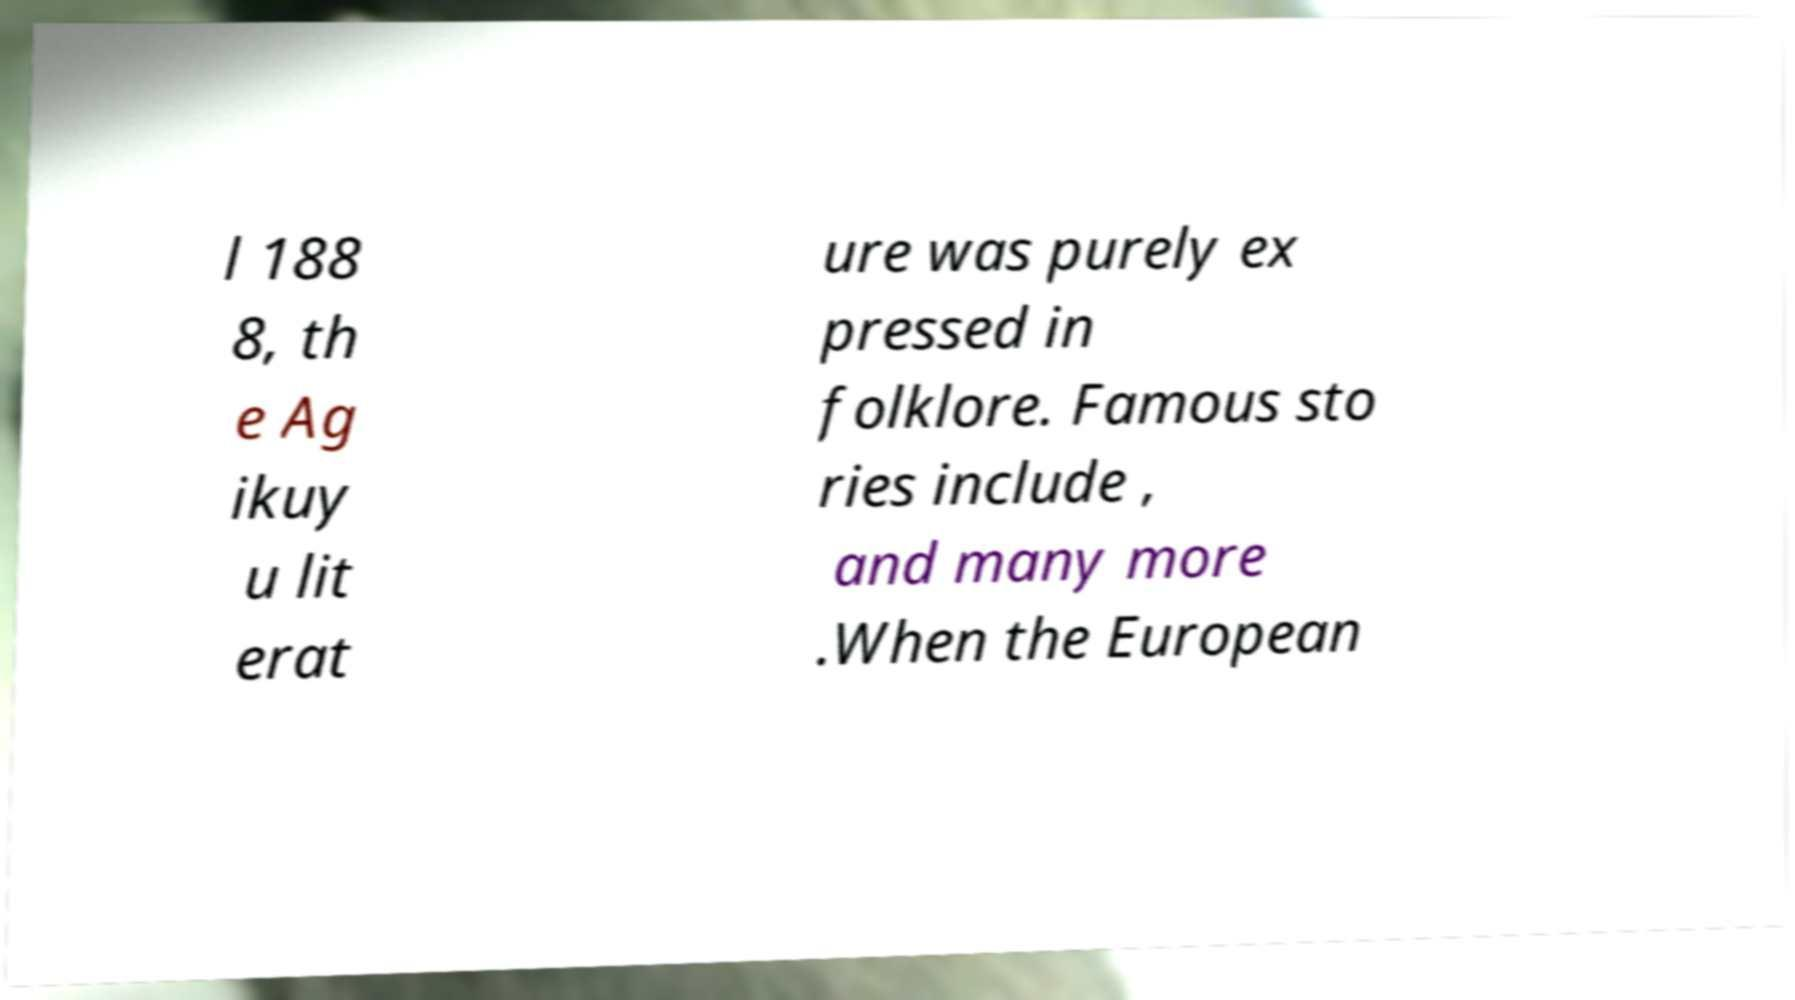There's text embedded in this image that I need extracted. Can you transcribe it verbatim? l 188 8, th e Ag ikuy u lit erat ure was purely ex pressed in folklore. Famous sto ries include , and many more .When the European 